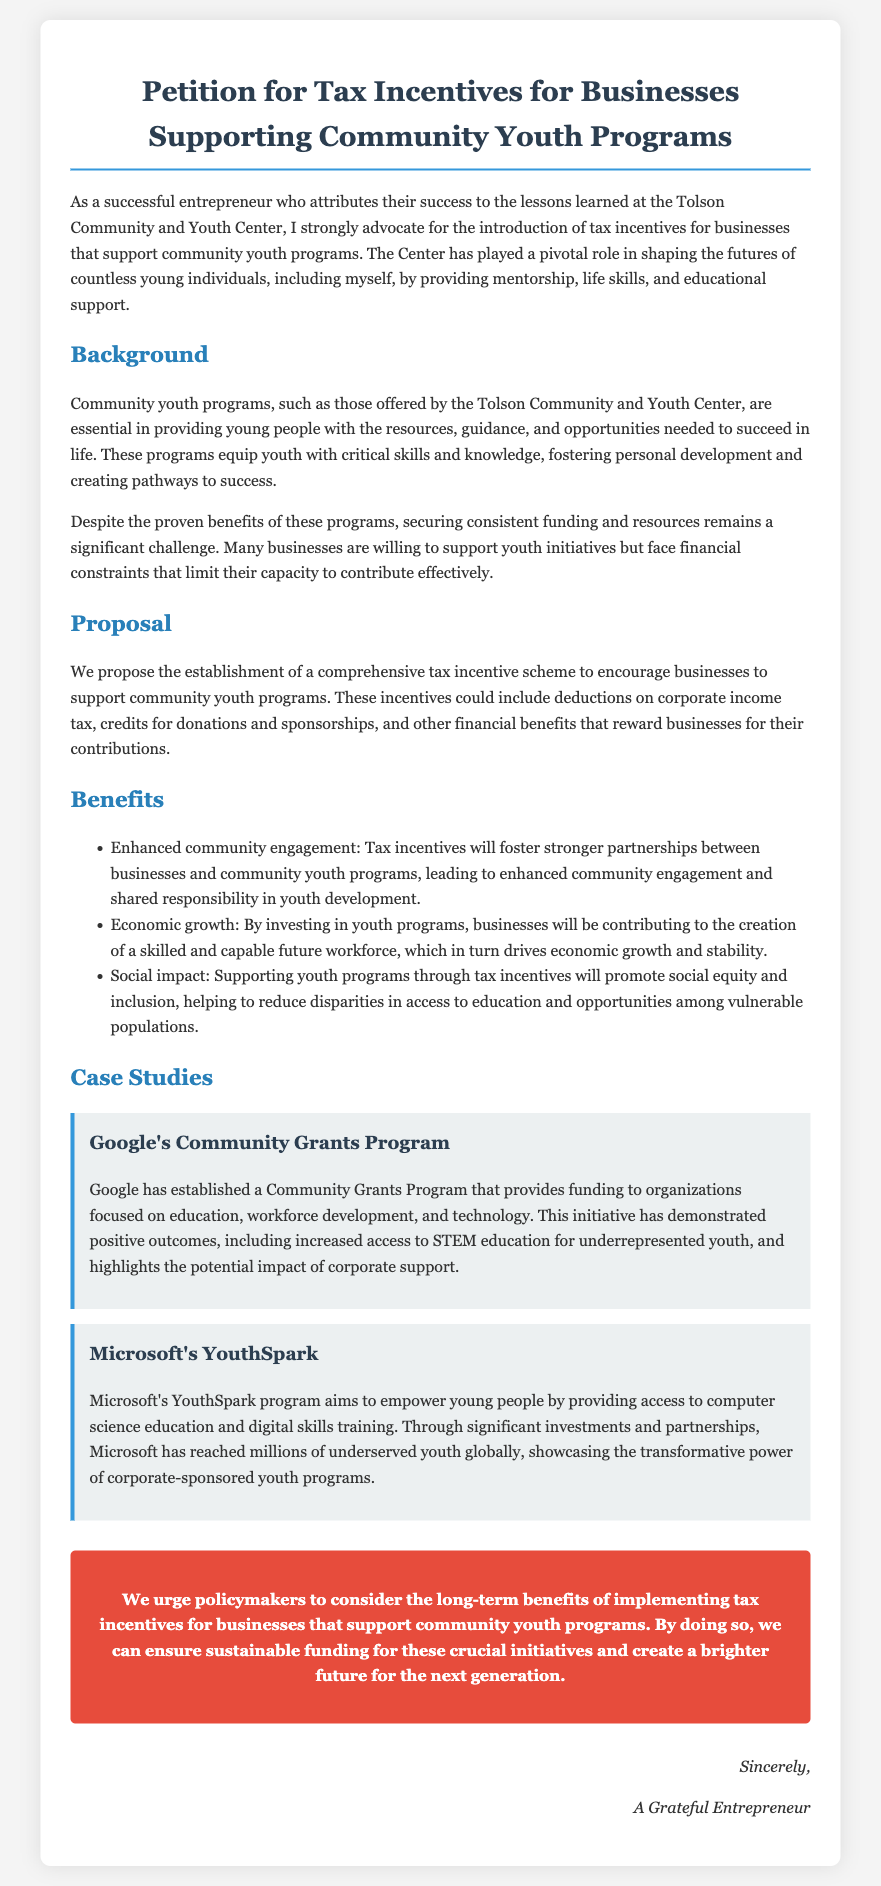What is the petition advocating for? The petition is advocating for tax incentives for businesses that support community youth programs.
Answer: Tax incentives What organization is mentioned in the petition? The organization mentioned is the Tolson Community and Youth Center.
Answer: Tolson Community and Youth Center What type of programs does the petition focus on? The petition focuses on community youth programs.
Answer: Community youth programs What are the proposed incentives for businesses? The proposed incentives include deductions on corporate income tax and credits for donations and sponsorships.
Answer: Deductions on corporate income tax, credits for donations and sponsorships What is one benefit of tax incentives mentioned in the document? One benefit mentioned is enhanced community engagement.
Answer: Enhanced community engagement How many corporate case studies are presented in the petition? There are two corporate case studies presented in the petition.
Answer: Two Which company's program aims to empower young people through computer science education? The company's program that aims to empower young people is Microsoft's YouthSpark.
Answer: Microsoft’s YouthSpark What is the main purpose of this petition? The main purpose is to ensure sustainable funding for community youth programs.
Answer: Sustainable funding for community youth programs Who signs off on the petition? The petition is signed off by "A Grateful Entrepreneur."
Answer: A Grateful Entrepreneur 